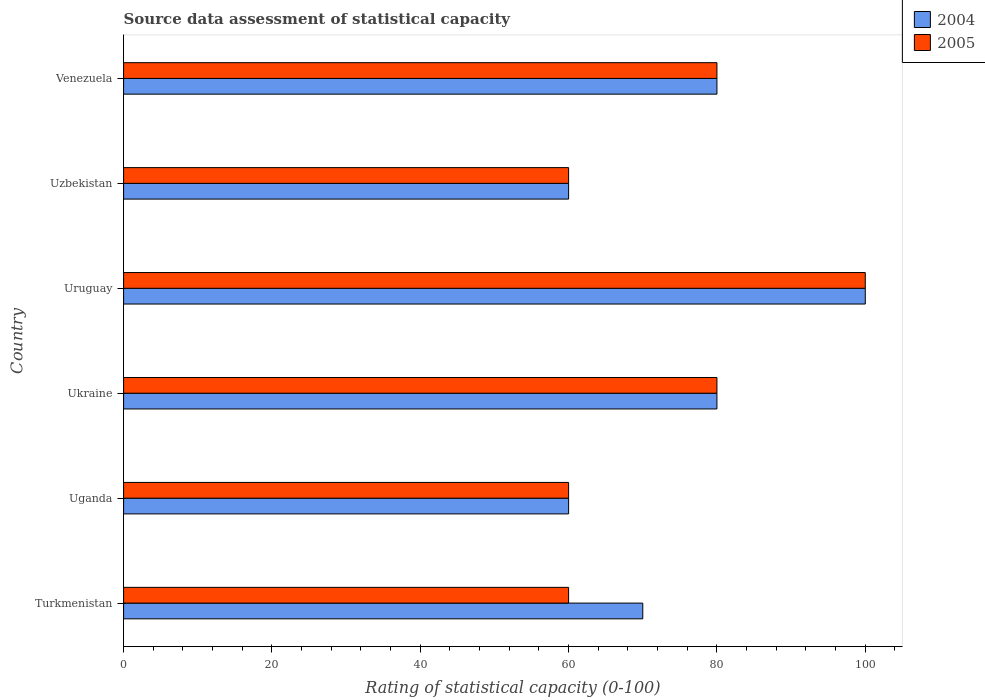How many different coloured bars are there?
Ensure brevity in your answer.  2. How many groups of bars are there?
Give a very brief answer. 6. What is the label of the 5th group of bars from the top?
Provide a succinct answer. Uganda. In how many cases, is the number of bars for a given country not equal to the number of legend labels?
Provide a short and direct response. 0. What is the rating of statistical capacity in 2004 in Uruguay?
Give a very brief answer. 100. Across all countries, what is the maximum rating of statistical capacity in 2004?
Your answer should be very brief. 100. Across all countries, what is the minimum rating of statistical capacity in 2004?
Make the answer very short. 60. In which country was the rating of statistical capacity in 2004 maximum?
Give a very brief answer. Uruguay. In which country was the rating of statistical capacity in 2004 minimum?
Your response must be concise. Uganda. What is the total rating of statistical capacity in 2005 in the graph?
Ensure brevity in your answer.  440. What is the difference between the rating of statistical capacity in 2004 in Uzbekistan and the rating of statistical capacity in 2005 in Venezuela?
Make the answer very short. -20. What is the difference between the rating of statistical capacity in 2005 and rating of statistical capacity in 2004 in Ukraine?
Offer a terse response. 0. In how many countries, is the rating of statistical capacity in 2005 greater than 44 ?
Keep it short and to the point. 6. What is the ratio of the rating of statistical capacity in 2004 in Ukraine to that in Uruguay?
Provide a short and direct response. 0.8. Is the difference between the rating of statistical capacity in 2005 in Uganda and Venezuela greater than the difference between the rating of statistical capacity in 2004 in Uganda and Venezuela?
Provide a succinct answer. No. What is the difference between the highest and the second highest rating of statistical capacity in 2005?
Ensure brevity in your answer.  20. Is the sum of the rating of statistical capacity in 2005 in Ukraine and Uzbekistan greater than the maximum rating of statistical capacity in 2004 across all countries?
Offer a terse response. Yes. How many bars are there?
Offer a terse response. 12. Are the values on the major ticks of X-axis written in scientific E-notation?
Provide a short and direct response. No. Does the graph contain any zero values?
Make the answer very short. No. Where does the legend appear in the graph?
Provide a short and direct response. Top right. How are the legend labels stacked?
Provide a short and direct response. Vertical. What is the title of the graph?
Keep it short and to the point. Source data assessment of statistical capacity. Does "1969" appear as one of the legend labels in the graph?
Give a very brief answer. No. What is the label or title of the X-axis?
Offer a very short reply. Rating of statistical capacity (0-100). What is the Rating of statistical capacity (0-100) of 2004 in Turkmenistan?
Offer a very short reply. 70. What is the Rating of statistical capacity (0-100) in 2005 in Turkmenistan?
Your answer should be very brief. 60. What is the Rating of statistical capacity (0-100) of 2004 in Uganda?
Provide a short and direct response. 60. What is the Rating of statistical capacity (0-100) in 2004 in Ukraine?
Make the answer very short. 80. What is the Rating of statistical capacity (0-100) in 2005 in Ukraine?
Make the answer very short. 80. What is the Rating of statistical capacity (0-100) in 2004 in Uzbekistan?
Your answer should be very brief. 60. What is the Rating of statistical capacity (0-100) of 2004 in Venezuela?
Give a very brief answer. 80. What is the Rating of statistical capacity (0-100) in 2005 in Venezuela?
Give a very brief answer. 80. What is the total Rating of statistical capacity (0-100) of 2004 in the graph?
Keep it short and to the point. 450. What is the total Rating of statistical capacity (0-100) of 2005 in the graph?
Make the answer very short. 440. What is the difference between the Rating of statistical capacity (0-100) of 2004 in Turkmenistan and that in Uganda?
Provide a short and direct response. 10. What is the difference between the Rating of statistical capacity (0-100) in 2004 in Turkmenistan and that in Ukraine?
Your response must be concise. -10. What is the difference between the Rating of statistical capacity (0-100) of 2004 in Turkmenistan and that in Uruguay?
Provide a succinct answer. -30. What is the difference between the Rating of statistical capacity (0-100) in 2004 in Turkmenistan and that in Uzbekistan?
Provide a short and direct response. 10. What is the difference between the Rating of statistical capacity (0-100) of 2005 in Turkmenistan and that in Uzbekistan?
Ensure brevity in your answer.  0. What is the difference between the Rating of statistical capacity (0-100) in 2004 in Turkmenistan and that in Venezuela?
Your answer should be very brief. -10. What is the difference between the Rating of statistical capacity (0-100) in 2005 in Turkmenistan and that in Venezuela?
Provide a succinct answer. -20. What is the difference between the Rating of statistical capacity (0-100) of 2004 in Uganda and that in Ukraine?
Make the answer very short. -20. What is the difference between the Rating of statistical capacity (0-100) in 2004 in Uganda and that in Uruguay?
Offer a terse response. -40. What is the difference between the Rating of statistical capacity (0-100) of 2004 in Uganda and that in Uzbekistan?
Keep it short and to the point. 0. What is the difference between the Rating of statistical capacity (0-100) of 2005 in Ukraine and that in Uzbekistan?
Provide a short and direct response. 20. What is the difference between the Rating of statistical capacity (0-100) of 2004 in Uruguay and that in Uzbekistan?
Your answer should be very brief. 40. What is the difference between the Rating of statistical capacity (0-100) in 2005 in Uruguay and that in Uzbekistan?
Offer a very short reply. 40. What is the difference between the Rating of statistical capacity (0-100) in 2005 in Uzbekistan and that in Venezuela?
Ensure brevity in your answer.  -20. What is the difference between the Rating of statistical capacity (0-100) in 2004 in Turkmenistan and the Rating of statistical capacity (0-100) in 2005 in Uganda?
Make the answer very short. 10. What is the difference between the Rating of statistical capacity (0-100) of 2004 in Turkmenistan and the Rating of statistical capacity (0-100) of 2005 in Ukraine?
Offer a terse response. -10. What is the difference between the Rating of statistical capacity (0-100) of 2004 in Turkmenistan and the Rating of statistical capacity (0-100) of 2005 in Uruguay?
Make the answer very short. -30. What is the difference between the Rating of statistical capacity (0-100) in 2004 in Turkmenistan and the Rating of statistical capacity (0-100) in 2005 in Venezuela?
Your answer should be compact. -10. What is the difference between the Rating of statistical capacity (0-100) in 2004 in Uganda and the Rating of statistical capacity (0-100) in 2005 in Ukraine?
Provide a short and direct response. -20. What is the difference between the Rating of statistical capacity (0-100) of 2004 in Uganda and the Rating of statistical capacity (0-100) of 2005 in Uruguay?
Your answer should be compact. -40. What is the difference between the Rating of statistical capacity (0-100) of 2004 in Uganda and the Rating of statistical capacity (0-100) of 2005 in Uzbekistan?
Your answer should be compact. 0. What is the difference between the Rating of statistical capacity (0-100) of 2004 in Ukraine and the Rating of statistical capacity (0-100) of 2005 in Uzbekistan?
Offer a terse response. 20. What is the difference between the Rating of statistical capacity (0-100) in 2004 in Ukraine and the Rating of statistical capacity (0-100) in 2005 in Venezuela?
Make the answer very short. 0. What is the difference between the Rating of statistical capacity (0-100) of 2004 in Uzbekistan and the Rating of statistical capacity (0-100) of 2005 in Venezuela?
Your answer should be compact. -20. What is the average Rating of statistical capacity (0-100) of 2004 per country?
Your answer should be very brief. 75. What is the average Rating of statistical capacity (0-100) in 2005 per country?
Provide a short and direct response. 73.33. What is the difference between the Rating of statistical capacity (0-100) in 2004 and Rating of statistical capacity (0-100) in 2005 in Uganda?
Ensure brevity in your answer.  0. What is the ratio of the Rating of statistical capacity (0-100) in 2004 in Turkmenistan to that in Ukraine?
Give a very brief answer. 0.88. What is the ratio of the Rating of statistical capacity (0-100) of 2004 in Turkmenistan to that in Uzbekistan?
Give a very brief answer. 1.17. What is the ratio of the Rating of statistical capacity (0-100) in 2005 in Turkmenistan to that in Uzbekistan?
Provide a succinct answer. 1. What is the ratio of the Rating of statistical capacity (0-100) of 2004 in Uganda to that in Ukraine?
Your answer should be compact. 0.75. What is the ratio of the Rating of statistical capacity (0-100) of 2004 in Uganda to that in Uruguay?
Offer a terse response. 0.6. What is the ratio of the Rating of statistical capacity (0-100) of 2004 in Uganda to that in Uzbekistan?
Offer a very short reply. 1. What is the ratio of the Rating of statistical capacity (0-100) in 2005 in Uganda to that in Uzbekistan?
Offer a terse response. 1. What is the ratio of the Rating of statistical capacity (0-100) in 2004 in Uganda to that in Venezuela?
Keep it short and to the point. 0.75. What is the ratio of the Rating of statistical capacity (0-100) of 2005 in Uganda to that in Venezuela?
Give a very brief answer. 0.75. What is the ratio of the Rating of statistical capacity (0-100) in 2005 in Ukraine to that in Uruguay?
Ensure brevity in your answer.  0.8. What is the ratio of the Rating of statistical capacity (0-100) in 2005 in Ukraine to that in Venezuela?
Provide a succinct answer. 1. What is the ratio of the Rating of statistical capacity (0-100) of 2004 in Uruguay to that in Venezuela?
Offer a terse response. 1.25. What is the ratio of the Rating of statistical capacity (0-100) of 2005 in Uruguay to that in Venezuela?
Give a very brief answer. 1.25. What is the ratio of the Rating of statistical capacity (0-100) in 2005 in Uzbekistan to that in Venezuela?
Give a very brief answer. 0.75. What is the difference between the highest and the second highest Rating of statistical capacity (0-100) in 2004?
Give a very brief answer. 20. What is the difference between the highest and the second highest Rating of statistical capacity (0-100) in 2005?
Your response must be concise. 20. What is the difference between the highest and the lowest Rating of statistical capacity (0-100) of 2004?
Keep it short and to the point. 40. 